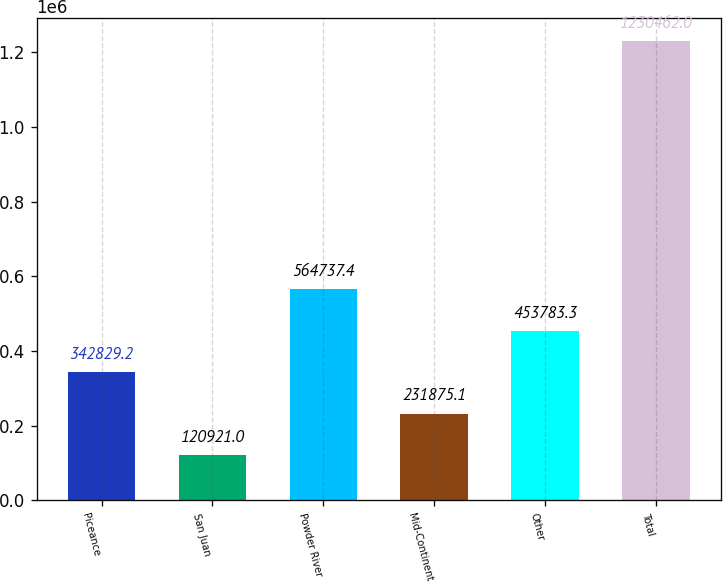<chart> <loc_0><loc_0><loc_500><loc_500><bar_chart><fcel>Piceance<fcel>San Juan<fcel>Powder River<fcel>Mid-Continent<fcel>Other<fcel>Total<nl><fcel>342829<fcel>120921<fcel>564737<fcel>231875<fcel>453783<fcel>1.23046e+06<nl></chart> 